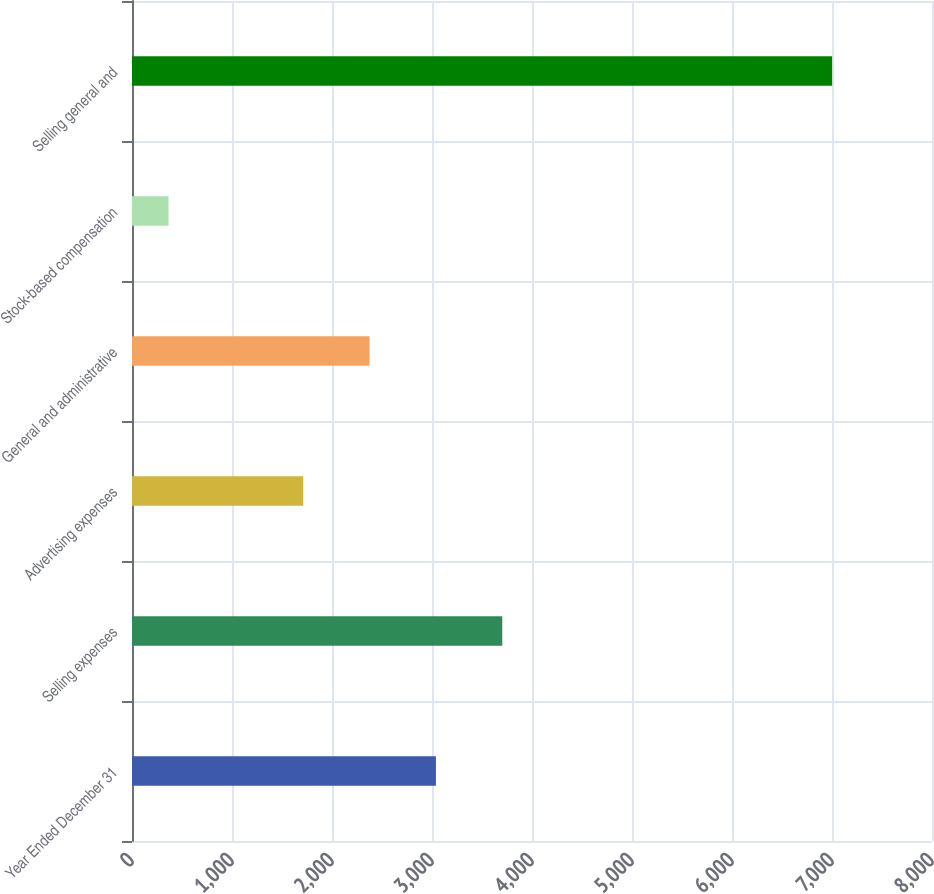Convert chart to OTSL. <chart><loc_0><loc_0><loc_500><loc_500><bar_chart><fcel>Year Ended December 31<fcel>Selling expenses<fcel>Advertising expenses<fcel>General and administrative<fcel>Stock-based compensation<fcel>Selling general and<nl><fcel>3039.2<fcel>3702.8<fcel>1712<fcel>2375.6<fcel>365<fcel>7001<nl></chart> 